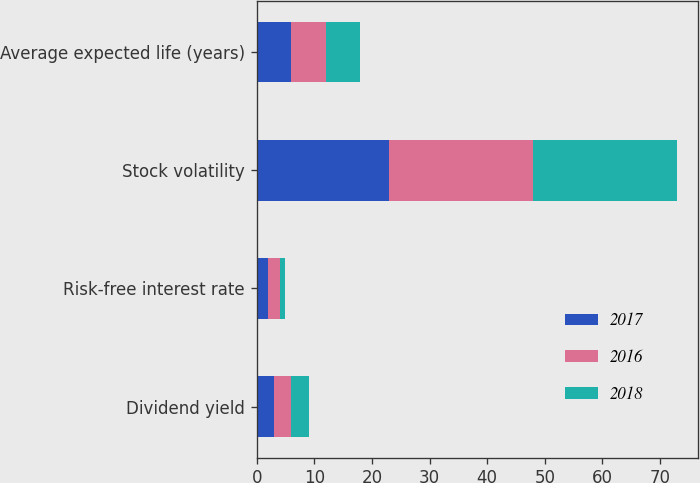Convert chart. <chart><loc_0><loc_0><loc_500><loc_500><stacked_bar_chart><ecel><fcel>Dividend yield<fcel>Risk-free interest rate<fcel>Stock volatility<fcel>Average expected life (years)<nl><fcel>2017<fcel>3<fcel>2<fcel>23<fcel>6<nl><fcel>2016<fcel>3<fcel>2<fcel>25<fcel>6<nl><fcel>2018<fcel>3<fcel>1<fcel>25<fcel>6<nl></chart> 